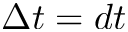Convert formula to latex. <formula><loc_0><loc_0><loc_500><loc_500>\Delta t = d t</formula> 